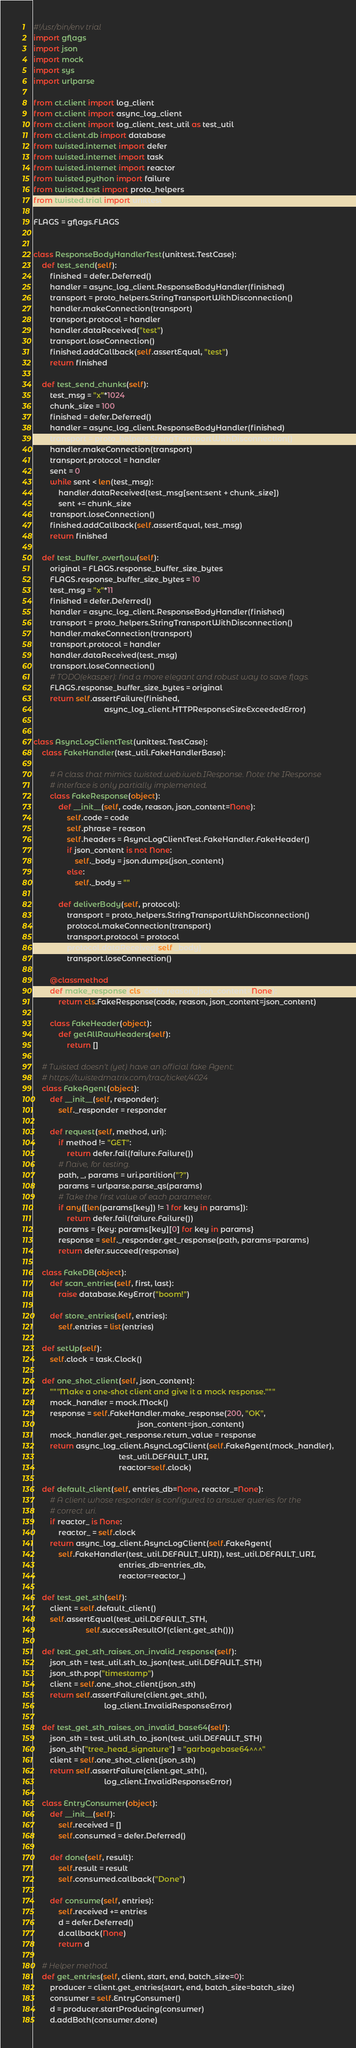Convert code to text. <code><loc_0><loc_0><loc_500><loc_500><_Python_>#!/usr/bin/env trial
import gflags
import json
import mock
import sys
import urlparse

from ct.client import log_client
from ct.client import async_log_client
from ct.client import log_client_test_util as test_util
from ct.client.db import database
from twisted.internet import defer
from twisted.internet import task
from twisted.internet import reactor
from twisted.python import failure
from twisted.test import proto_helpers
from twisted.trial import unittest

FLAGS = gflags.FLAGS


class ResponseBodyHandlerTest(unittest.TestCase):
    def test_send(self):
        finished = defer.Deferred()
        handler = async_log_client.ResponseBodyHandler(finished)
        transport = proto_helpers.StringTransportWithDisconnection()
        handler.makeConnection(transport)
        transport.protocol = handler
        handler.dataReceived("test")
        transport.loseConnection()
        finished.addCallback(self.assertEqual, "test")
        return finished

    def test_send_chunks(self):
        test_msg = "x"*1024
        chunk_size = 100
        finished = defer.Deferred()
        handler = async_log_client.ResponseBodyHandler(finished)
        transport = proto_helpers.StringTransportWithDisconnection()
        handler.makeConnection(transport)
        transport.protocol = handler
        sent = 0
        while sent < len(test_msg):
            handler.dataReceived(test_msg[sent:sent + chunk_size])
            sent += chunk_size
        transport.loseConnection()
        finished.addCallback(self.assertEqual, test_msg)
        return finished

    def test_buffer_overflow(self):
        original = FLAGS.response_buffer_size_bytes
        FLAGS.response_buffer_size_bytes = 10
        test_msg = "x"*11
        finished = defer.Deferred()
        handler = async_log_client.ResponseBodyHandler(finished)
        transport = proto_helpers.StringTransportWithDisconnection()
        handler.makeConnection(transport)
        transport.protocol = handler
        handler.dataReceived(test_msg)
        transport.loseConnection()
        # TODO(ekasper): find a more elegant and robust way to save flags.
        FLAGS.response_buffer_size_bytes = original
        return self.assertFailure(finished,
                                  async_log_client.HTTPResponseSizeExceededError)


class AsyncLogClientTest(unittest.TestCase):
    class FakeHandler(test_util.FakeHandlerBase):

        # A class that mimics twisted.web.iweb.IResponse. Note: the IResponse
        # interface is only partially implemented.
        class FakeResponse(object):
            def __init__(self, code, reason, json_content=None):
                self.code = code
                self.phrase = reason
                self.headers = AsyncLogClientTest.FakeHandler.FakeHeader()
                if json_content is not None:
                    self._body = json.dumps(json_content)
                else:
                    self._body = ""

            def deliverBody(self, protocol):
                transport = proto_helpers.StringTransportWithDisconnection()
                protocol.makeConnection(transport)
                transport.protocol = protocol
                protocol.dataReceived(self._body)
                transport.loseConnection()

        @classmethod
        def make_response(cls, code, reason, json_content=None):
            return cls.FakeResponse(code, reason, json_content=json_content)

        class FakeHeader(object):
            def getAllRawHeaders(self):
                return []

    # Twisted doesn't (yet) have an official fake Agent:
    # https://twistedmatrix.com/trac/ticket/4024
    class FakeAgent(object):
        def __init__(self, responder):
            self._responder = responder

        def request(self, method, uri):
            if method != "GET":
                return defer.fail(failure.Failure())
            # Naive, for testing.
            path, _, params = uri.partition("?")
            params = urlparse.parse_qs(params)
            # Take the first value of each parameter.
            if any([len(params[key]) != 1 for key in params]):
                return defer.fail(failure.Failure())
            params = {key: params[key][0] for key in params}
            response = self._responder.get_response(path, params=params)
            return defer.succeed(response)

    class FakeDB(object):
        def scan_entries(self, first, last):
            raise database.KeyError("boom!")

        def store_entries(self, entries):
            self.entries = list(entries)

    def setUp(self):
        self.clock = task.Clock()

    def one_shot_client(self, json_content):
        """Make a one-shot client and give it a mock response."""
        mock_handler = mock.Mock()
        response = self.FakeHandler.make_response(200, "OK",
                                                  json_content=json_content)
        mock_handler.get_response.return_value = response
        return async_log_client.AsyncLogClient(self.FakeAgent(mock_handler),
                                         test_util.DEFAULT_URI,
                                         reactor=self.clock)

    def default_client(self, entries_db=None, reactor_=None):
        # A client whose responder is configured to answer queries for the
        # correct uri.
        if reactor_ is None:
            reactor_ = self.clock
        return async_log_client.AsyncLogClient(self.FakeAgent(
            self.FakeHandler(test_util.DEFAULT_URI)), test_util.DEFAULT_URI,
                                         entries_db=entries_db,
                                         reactor=reactor_)

    def test_get_sth(self):
        client = self.default_client()
        self.assertEqual(test_util.DEFAULT_STH,
                         self.successResultOf(client.get_sth()))

    def test_get_sth_raises_on_invalid_response(self):
        json_sth = test_util.sth_to_json(test_util.DEFAULT_STH)
        json_sth.pop("timestamp")
        client = self.one_shot_client(json_sth)
        return self.assertFailure(client.get_sth(),
                                  log_client.InvalidResponseError)

    def test_get_sth_raises_on_invalid_base64(self):
        json_sth = test_util.sth_to_json(test_util.DEFAULT_STH)
        json_sth["tree_head_signature"] = "garbagebase64^^^"
        client = self.one_shot_client(json_sth)
        return self.assertFailure(client.get_sth(),
                                  log_client.InvalidResponseError)

    class EntryConsumer(object):
        def __init__(self):
            self.received = []
            self.consumed = defer.Deferred()

        def done(self, result):
            self.result = result
            self.consumed.callback("Done")

        def consume(self, entries):
            self.received += entries
            d = defer.Deferred()
            d.callback(None)
            return d

    # Helper method.
    def get_entries(self, client, start, end, batch_size=0):
        producer = client.get_entries(start, end, batch_size=batch_size)
        consumer = self.EntryConsumer()
        d = producer.startProducing(consumer)
        d.addBoth(consumer.done)</code> 